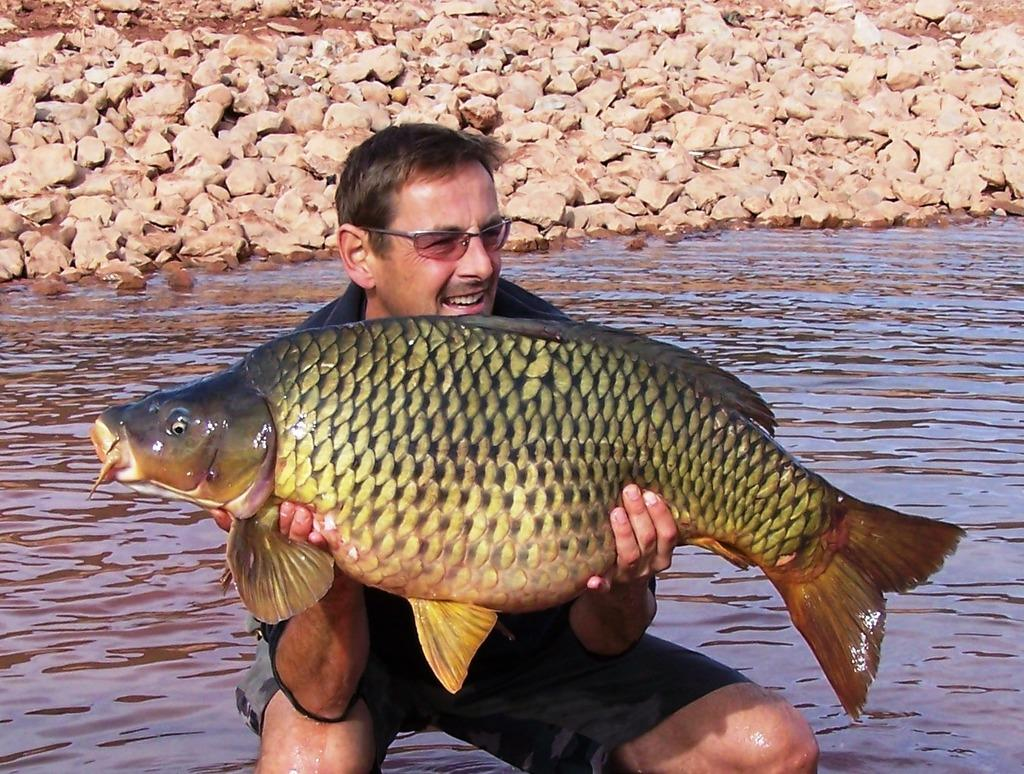Who or what is present in the image? There is a person in the image. What is the person doing in the image? The person is in the water and holding a fish in his hand. What can be seen in the background of the image? There are rocks behind the person. What is the primary element in which the person is situated? The person is in the water. How far away is the amusement park from the person in the image? There is no amusement park mentioned or visible in the image. What type of hen can be seen in the image? There are no hens present in the image. 